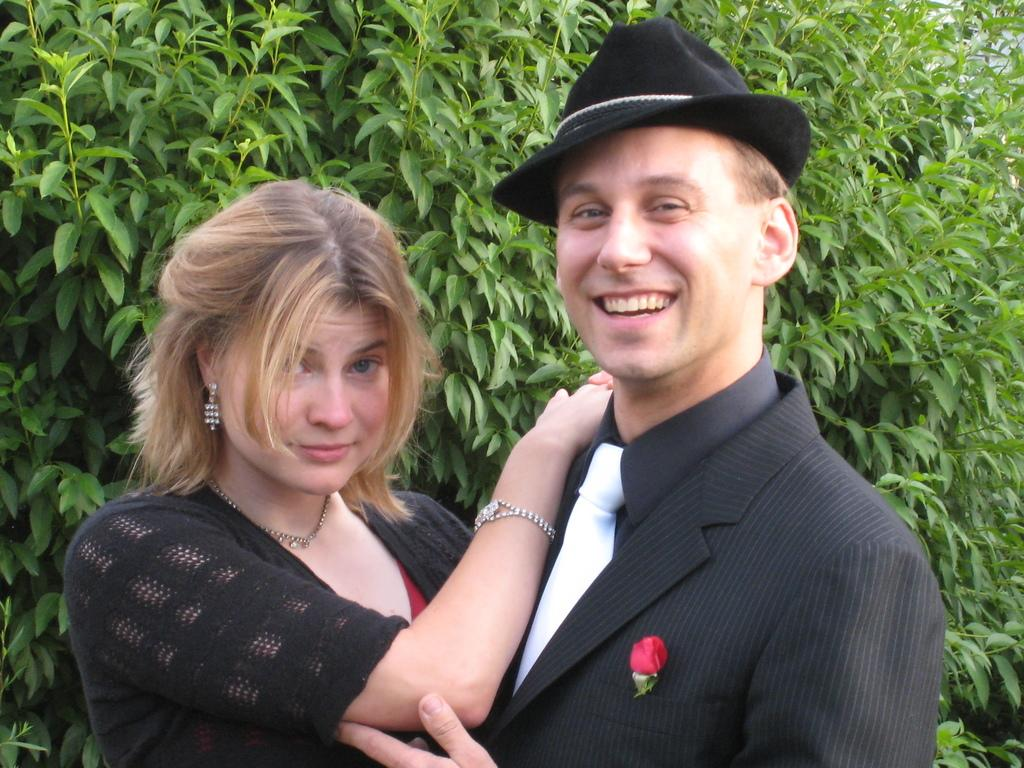Who are the people in the image? There is a woman and a man in the image. What is the man doing in the image? The man is smiling in the image. Can you describe any unique features of the man's attire? Yes, there is a flower on the man's suit. What can be seen in the background of the image? There are plants in the background of the image. What is the smell of the lake in the image? There is no lake present in the image, so it is not possible to determine the smell. 